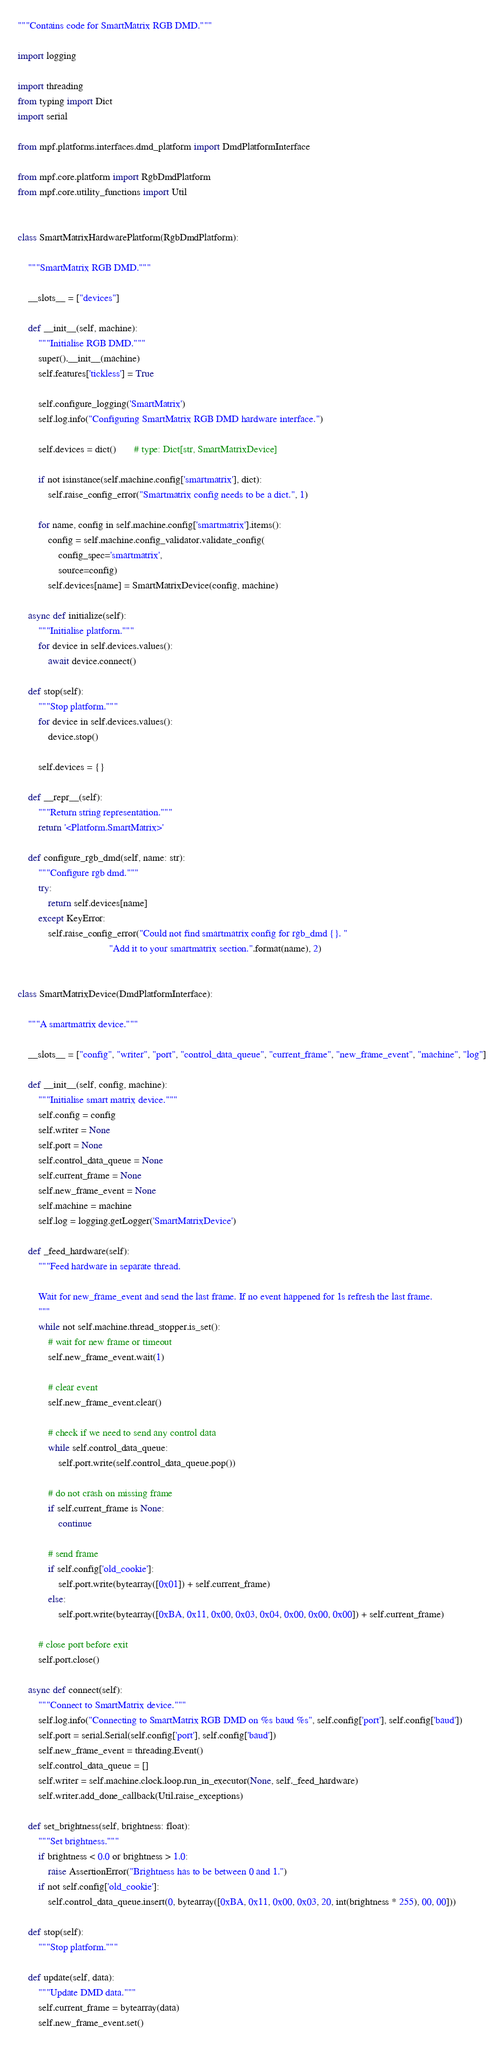Convert code to text. <code><loc_0><loc_0><loc_500><loc_500><_Python_>"""Contains code for SmartMatrix RGB DMD."""

import logging

import threading
from typing import Dict
import serial

from mpf.platforms.interfaces.dmd_platform import DmdPlatformInterface

from mpf.core.platform import RgbDmdPlatform
from mpf.core.utility_functions import Util


class SmartMatrixHardwarePlatform(RgbDmdPlatform):

    """SmartMatrix RGB DMD."""

    __slots__ = ["devices"]

    def __init__(self, machine):
        """Initialise RGB DMD."""
        super().__init__(machine)
        self.features['tickless'] = True

        self.configure_logging('SmartMatrix')
        self.log.info("Configuring SmartMatrix RGB DMD hardware interface.")

        self.devices = dict()       # type: Dict[str, SmartMatrixDevice]

        if not isinstance(self.machine.config['smartmatrix'], dict):
            self.raise_config_error("Smartmatrix config needs to be a dict.", 1)

        for name, config in self.machine.config['smartmatrix'].items():
            config = self.machine.config_validator.validate_config(
                config_spec='smartmatrix',
                source=config)
            self.devices[name] = SmartMatrixDevice(config, machine)

    async def initialize(self):
        """Initialise platform."""
        for device in self.devices.values():
            await device.connect()

    def stop(self):
        """Stop platform."""
        for device in self.devices.values():
            device.stop()

        self.devices = {}

    def __repr__(self):
        """Return string representation."""
        return '<Platform.SmartMatrix>'

    def configure_rgb_dmd(self, name: str):
        """Configure rgb dmd."""
        try:
            return self.devices[name]
        except KeyError:
            self.raise_config_error("Could not find smartmatrix config for rgb_dmd {}. "
                                    "Add it to your smartmatrix section.".format(name), 2)


class SmartMatrixDevice(DmdPlatformInterface):

    """A smartmatrix device."""

    __slots__ = ["config", "writer", "port", "control_data_queue", "current_frame", "new_frame_event", "machine", "log"]

    def __init__(self, config, machine):
        """Initialise smart matrix device."""
        self.config = config
        self.writer = None
        self.port = None
        self.control_data_queue = None
        self.current_frame = None
        self.new_frame_event = None
        self.machine = machine
        self.log = logging.getLogger('SmartMatrixDevice')

    def _feed_hardware(self):
        """Feed hardware in separate thread.

        Wait for new_frame_event and send the last frame. If no event happened for 1s refresh the last frame.
        """
        while not self.machine.thread_stopper.is_set():
            # wait for new frame or timeout
            self.new_frame_event.wait(1)

            # clear event
            self.new_frame_event.clear()

            # check if we need to send any control data
            while self.control_data_queue:
                self.port.write(self.control_data_queue.pop())

            # do not crash on missing frame
            if self.current_frame is None:
                continue

            # send frame
            if self.config['old_cookie']:
                self.port.write(bytearray([0x01]) + self.current_frame)
            else:
                self.port.write(bytearray([0xBA, 0x11, 0x00, 0x03, 0x04, 0x00, 0x00, 0x00]) + self.current_frame)

        # close port before exit
        self.port.close()

    async def connect(self):
        """Connect to SmartMatrix device."""
        self.log.info("Connecting to SmartMatrix RGB DMD on %s baud %s", self.config['port'], self.config['baud'])
        self.port = serial.Serial(self.config['port'], self.config['baud'])
        self.new_frame_event = threading.Event()
        self.control_data_queue = []
        self.writer = self.machine.clock.loop.run_in_executor(None, self._feed_hardware)
        self.writer.add_done_callback(Util.raise_exceptions)

    def set_brightness(self, brightness: float):
        """Set brightness."""
        if brightness < 0.0 or brightness > 1.0:
            raise AssertionError("Brightness has to be between 0 and 1.")
        if not self.config['old_cookie']:
            self.control_data_queue.insert(0, bytearray([0xBA, 0x11, 0x00, 0x03, 20, int(brightness * 255), 00, 00]))

    def stop(self):
        """Stop platform."""

    def update(self, data):
        """Update DMD data."""
        self.current_frame = bytearray(data)
        self.new_frame_event.set()
</code> 